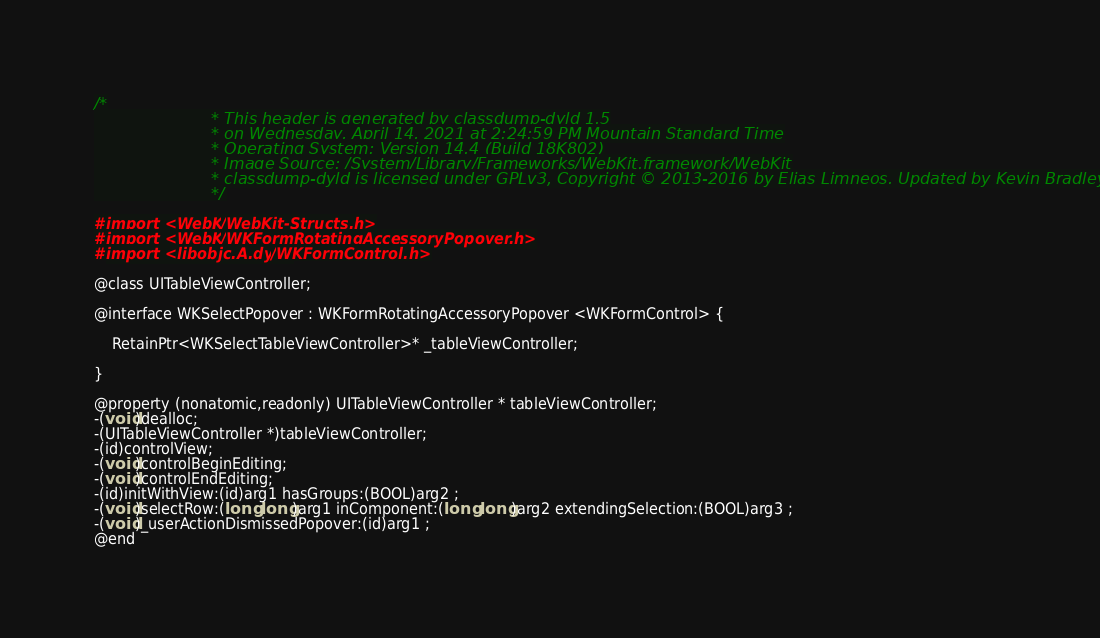<code> <loc_0><loc_0><loc_500><loc_500><_C_>/*
                       * This header is generated by classdump-dyld 1.5
                       * on Wednesday, April 14, 2021 at 2:24:59 PM Mountain Standard Time
                       * Operating System: Version 14.4 (Build 18K802)
                       * Image Source: /System/Library/Frameworks/WebKit.framework/WebKit
                       * classdump-dyld is licensed under GPLv3, Copyright © 2013-2016 by Elias Limneos. Updated by Kevin Bradley.
                       */

#import <WebKit/WebKit-Structs.h>
#import <WebKit/WKFormRotatingAccessoryPopover.h>
#import <libobjc.A.dylib/WKFormControl.h>

@class UITableViewController;

@interface WKSelectPopover : WKFormRotatingAccessoryPopover <WKFormControl> {

	RetainPtr<WKSelectTableViewController>* _tableViewController;

}

@property (nonatomic,readonly) UITableViewController * tableViewController; 
-(void)dealloc;
-(UITableViewController *)tableViewController;
-(id)controlView;
-(void)controlBeginEditing;
-(void)controlEndEditing;
-(id)initWithView:(id)arg1 hasGroups:(BOOL)arg2 ;
-(void)selectRow:(long long)arg1 inComponent:(long long)arg2 extendingSelection:(BOOL)arg3 ;
-(void)_userActionDismissedPopover:(id)arg1 ;
@end

</code> 